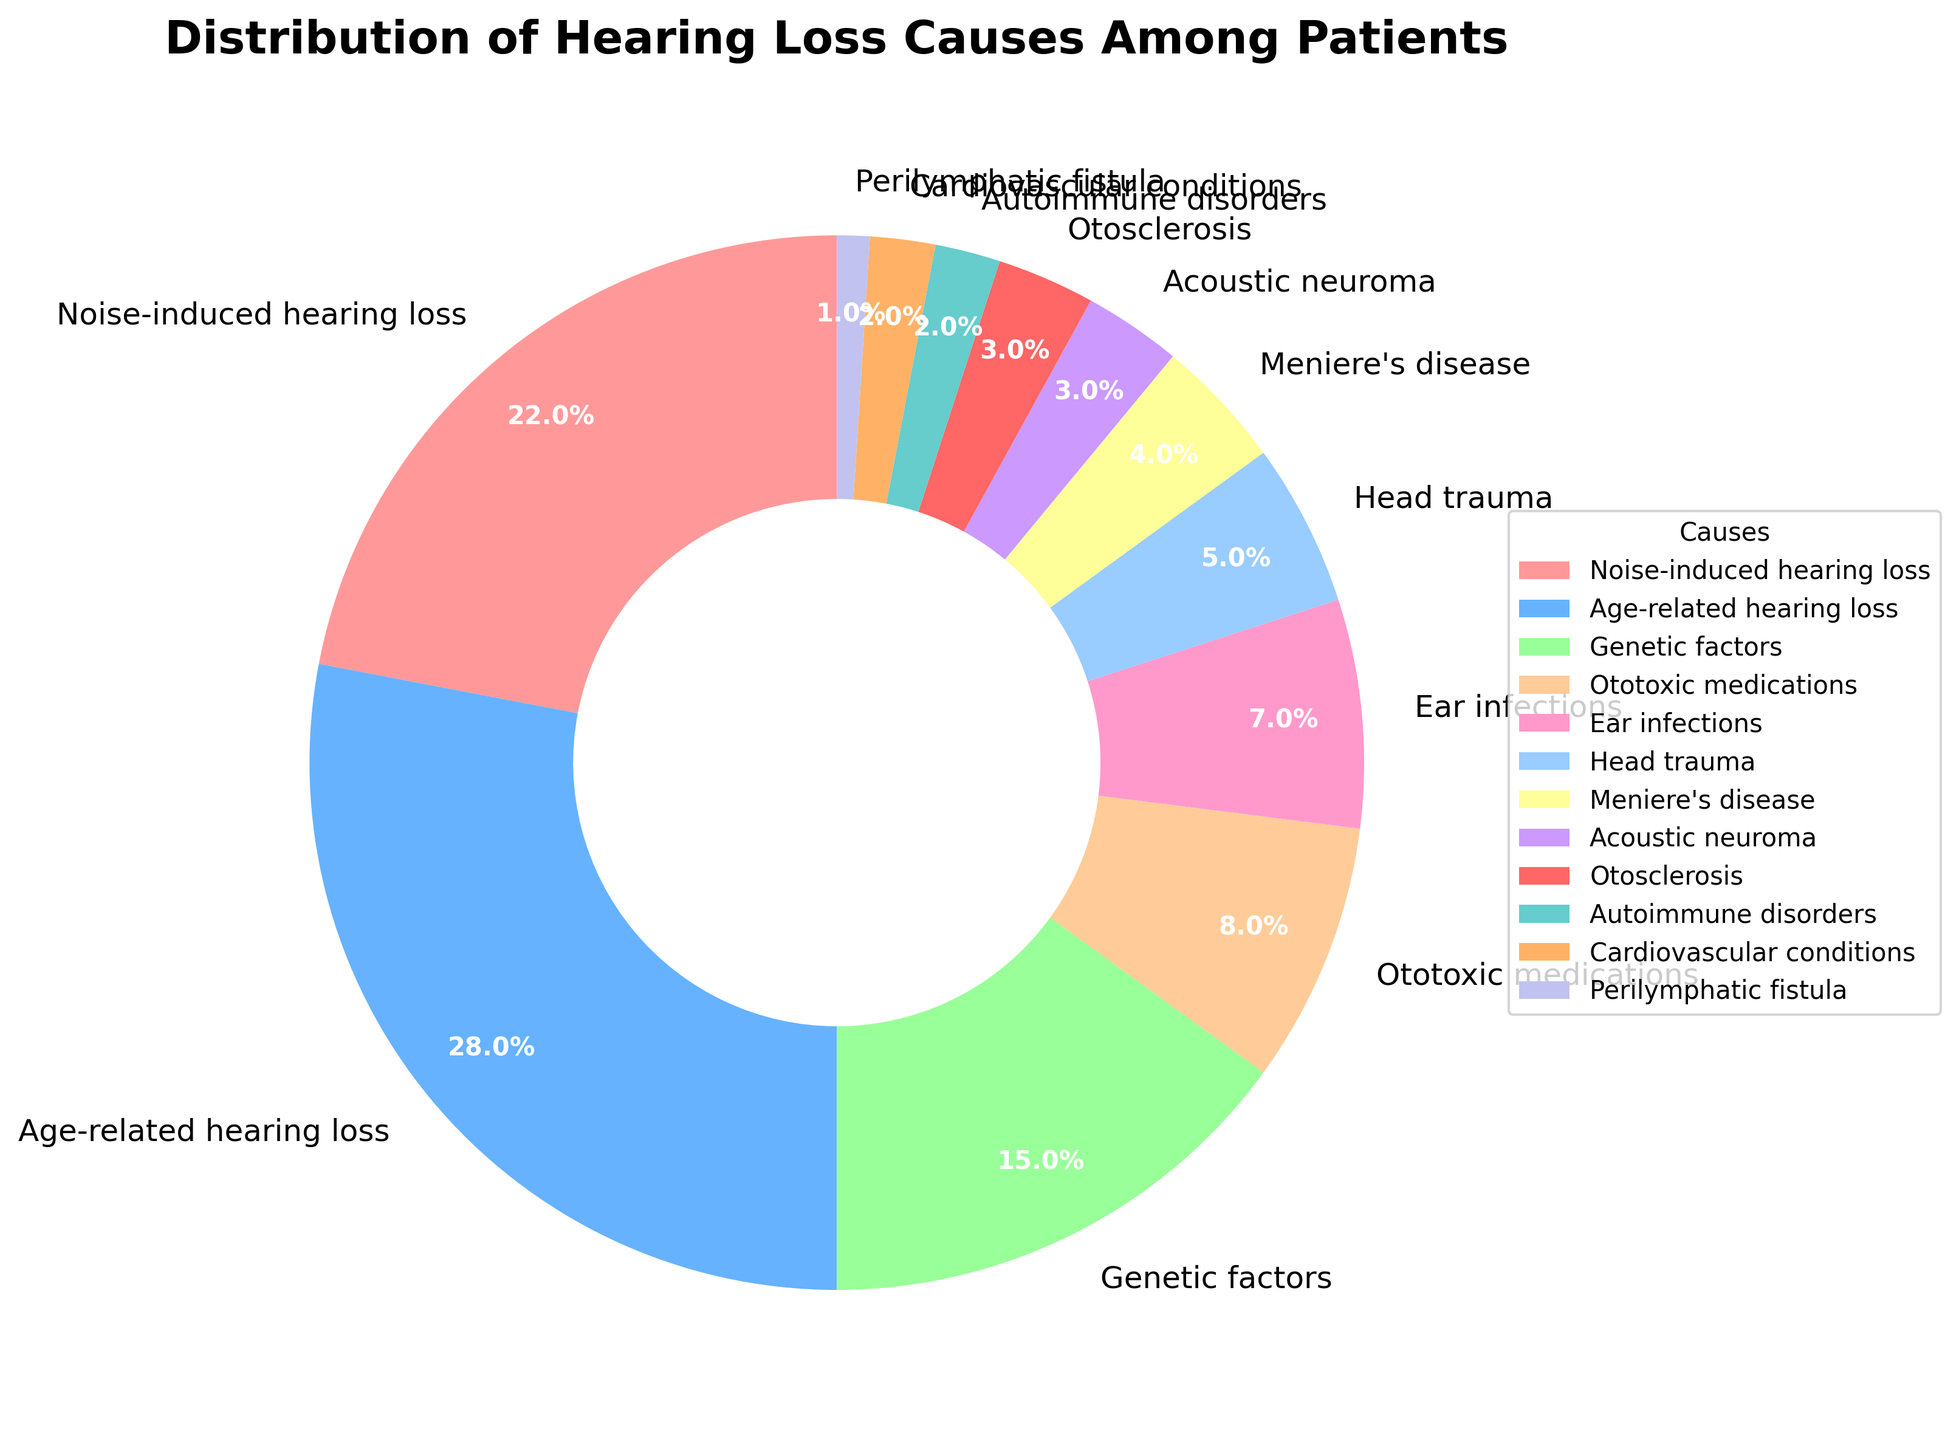What is the most common cause of hearing loss among patients? From the pie chart, the largest wedge represents Age-related hearing loss with 28%.
Answer: Age-related hearing loss Which two causes together make up 37% of the hearing loss among patients? The pie chart shows that Noise-induced hearing loss makes up 22% and Genetic factors make up 15%. Adding these two percentages gives 22 + 15 = 37%.
Answer: Noise-induced hearing loss and Genetic factors Which cause of hearing loss is represented by the green color wedge? The green color wedge in the pie chart is associated with Genetic factors.
Answer: Genetic factors Are there more patients with hearing loss due to head trauma or ear infections? Head trauma accounts for 5% and ear infections account for 7%, as seen in the pie chart. 7% (ear infections) is greater than 5% (head trauma).
Answer: Ear infections What is the combined percentage of hearing loss cases due to ototoxic medications, ear infections, and head trauma? From the pie chart, the percentages are 8% (ototoxic medications), 7% (ear infections), and 5% (head trauma). Adding them gives 8 + 7 + 5 = 20%.
Answer: 20% How does the number of patients with Noise-induced hearing loss compare to those with Ototoxic medications induced hearing loss? From the pie chart, Noise-induced hearing loss is 22% and Ototoxic medications are 8%. 22% is significantly higher than 8%.
Answer: Noise-induced hearing loss is higher Which causes of hearing loss have a representation of less than 5% each? From the pie chart, the causes with less than 5% are Meniere's disease (4%), Acoustic neuroma (3%), Otosclerosis (3%), Autoimmune disorders (2%), Cardiovascular conditions (2%), and Perilymphatic fistula (1%).
Answer: Meniere's disease, Acoustic neuroma, Otosclerosis, Autoimmune disorders, Cardiovascular conditions, Perilymphatic fistula What is the total percentage of hearing loss that is not age-related? Age-related hearing loss is 28%, so the total percentage that is not age-related is 100% - 28% = 72%.
Answer: 72% Which cause is visually closest to the ear infections wedge in terms of size? The values from the pie chart show that the wedge sizes closest to ear infections (7%) are Ototoxic medications (8%) and head trauma (5%).
Answer: Ototoxic medications and head trauma 